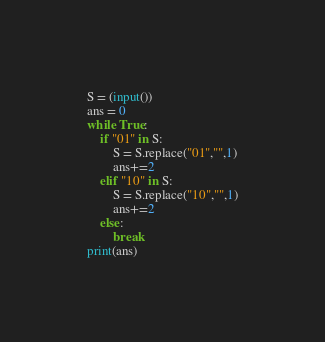<code> <loc_0><loc_0><loc_500><loc_500><_Python_>S = (input())
ans = 0
while True:
    if "01" in S:
        S = S.replace("01","",1)
        ans+=2
    elif "10" in S:
        S = S.replace("10","",1)
        ans+=2
    else:
        break
print(ans)</code> 